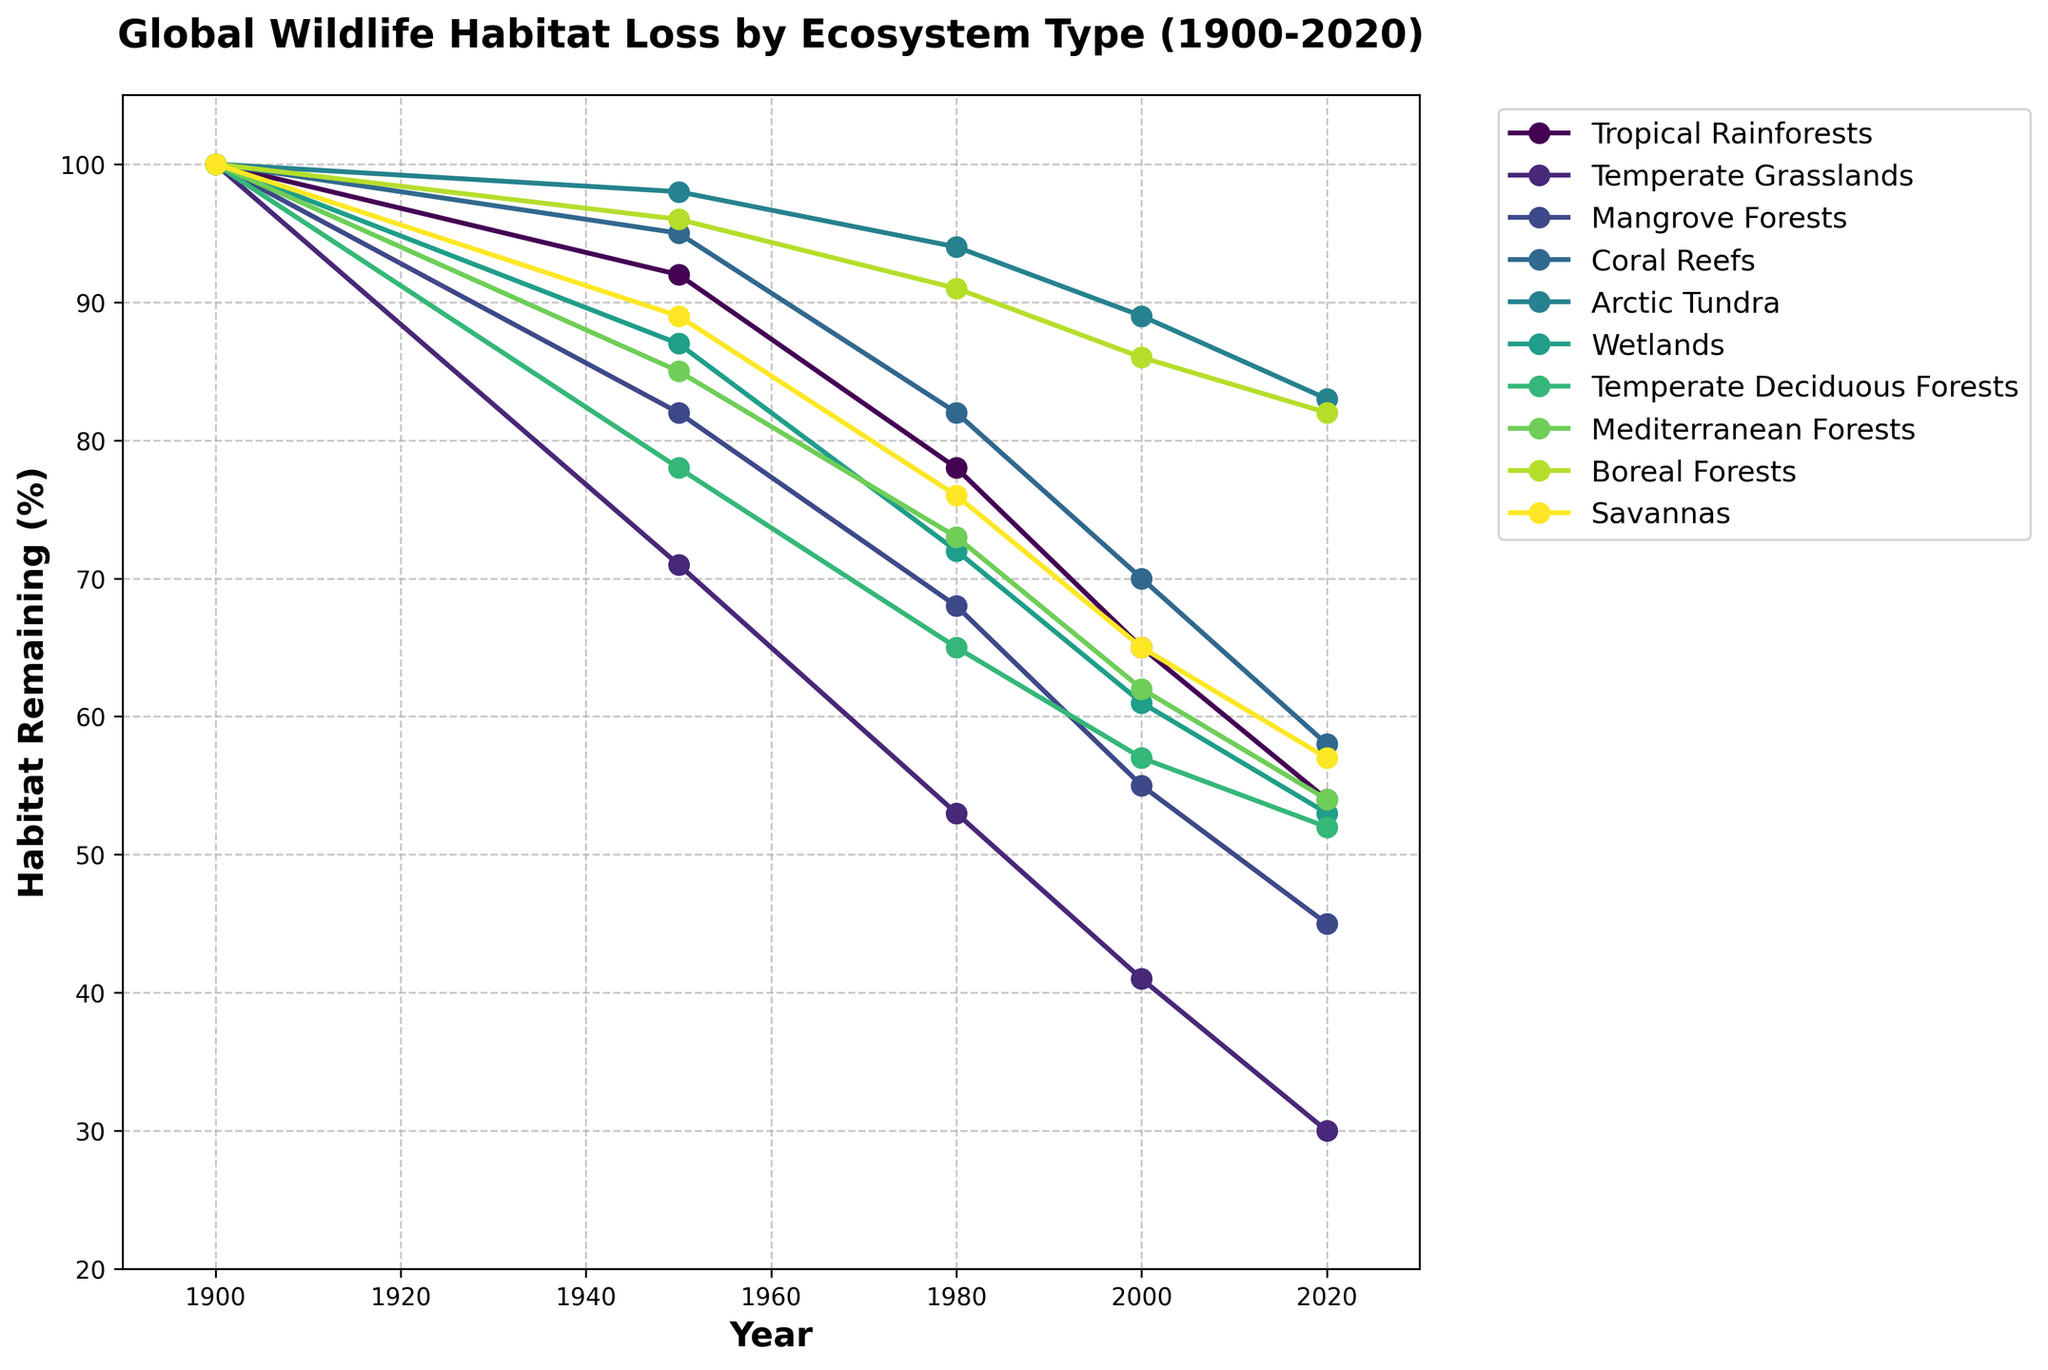what percentage of Tropical Rainforests' habitat remained in 2020? Look at the Tropical Rainforests line in the chart and read the value corresponding to 2020
Answer: 54 which ecosystem had the least habitat remaining in 2020? Compare the 2020 data points for all ecosystems on the chart. The lowest point is for Temperate Grasslands
Answer: Temperate Grasslands What is the difference between the percentage of habitat remaining for Coral Reefs and Arctic Tundra in 2000? Find the values for Coral Reefs and Arctic Tundra in 2000: Coral Reefs (70) and Arctic Tundra (89). Subtract the Coral Reefs value from the Arctic Tundra value: 89 - 70 = 19
Answer: 19 How many ecosystems had more than 80% of their habitat remaining in 1950? Check the data points for 1950. Tropical Rainforests (92), Mangrove Forests (82), Coral Reefs (95), Arctic Tundra (98), and Boreal Forests (96) are above 80%
Answer: 5 Compositional: What is the average percentage of habitat remaining for Wetlands from 1980 to 2020? Look at the values for Wetlands from 1980 to 2020: 72, 61, 53. Sum them and divide by the number of years: (72 + 61 + 53) / 3 = 186 / 3 = 62
Answer: 62 Which ecosystem exhibited the smallest decline in habitat percentage from 1900 to 2020? Subtract the 2020 values from the 1900 values for each ecosystem, then compare. Arctic Tundra has the smallest decline: 100 - 83 = 17
Answer: Arctic Tundra Visual: Which ecosystem's line is the steepest downward slope from 1900 to 1980? Observe the slope of the lines between 1900 to 1980, the steeper the line, the greater the decline. Temperate Grasslands have the steepest slope
Answer: Temperate Grasslands By how many points did the habitat percentage of Mediterranean Forests decrease from 2000 to 2020? Find the values for Mediterranean Forests in 2000 and 2020: 62 and 54. Subtract 54 from 62: 62 - 54 = 8
Answer: 8 Compare the habitat remaining percentage of Temperate Deciduous Forests and Savannas in 1980. Which ecosystem had a higher percentage? Locate the values for both ecosystems in the chart for 1980: Temperate Deciduous Forests (65) and Savannas (76). Savannas have a higher percentage
Answer: Savannas What trend does the data show about habitat loss across all the ecosystems from 1900? The lines for all ecosystems show a downward trend from 1900 to 2020, indicating habitat loss over the period
Answer: Downward trend 